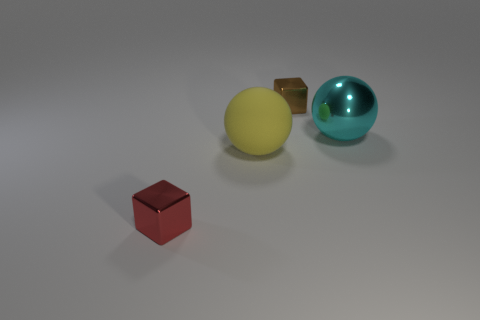Add 3 matte objects. How many objects exist? 7 Add 1 cyan shiny objects. How many cyan shiny objects exist? 2 Subtract 0 red cylinders. How many objects are left? 4 Subtract all tiny red shiny cylinders. Subtract all small blocks. How many objects are left? 2 Add 3 yellow matte spheres. How many yellow matte spheres are left? 4 